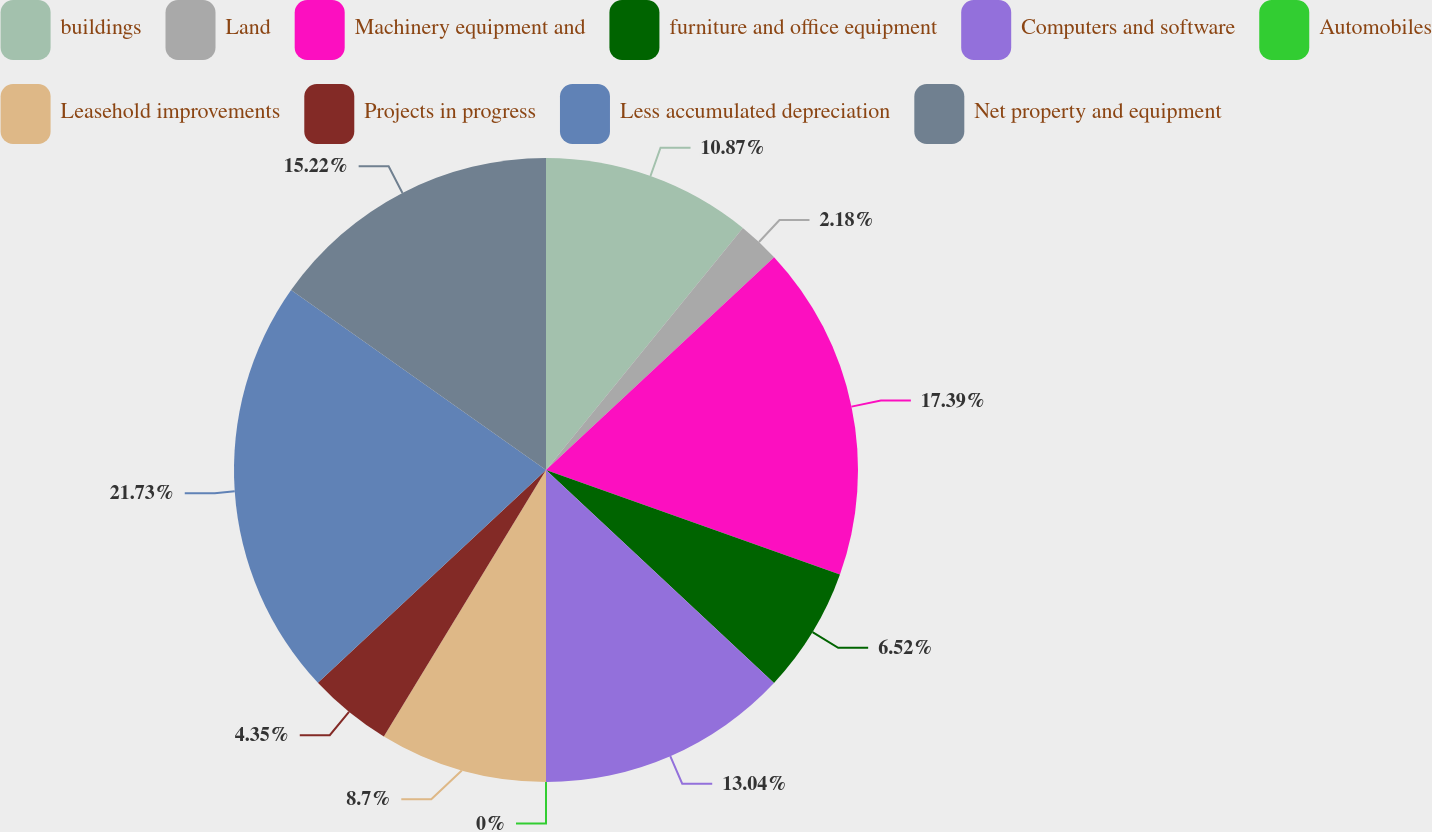Convert chart. <chart><loc_0><loc_0><loc_500><loc_500><pie_chart><fcel>buildings<fcel>Land<fcel>Machinery equipment and<fcel>furniture and office equipment<fcel>Computers and software<fcel>Automobiles<fcel>Leasehold improvements<fcel>Projects in progress<fcel>Less accumulated depreciation<fcel>Net property and equipment<nl><fcel>10.87%<fcel>2.18%<fcel>17.39%<fcel>6.52%<fcel>13.04%<fcel>0.0%<fcel>8.7%<fcel>4.35%<fcel>21.73%<fcel>15.22%<nl></chart> 